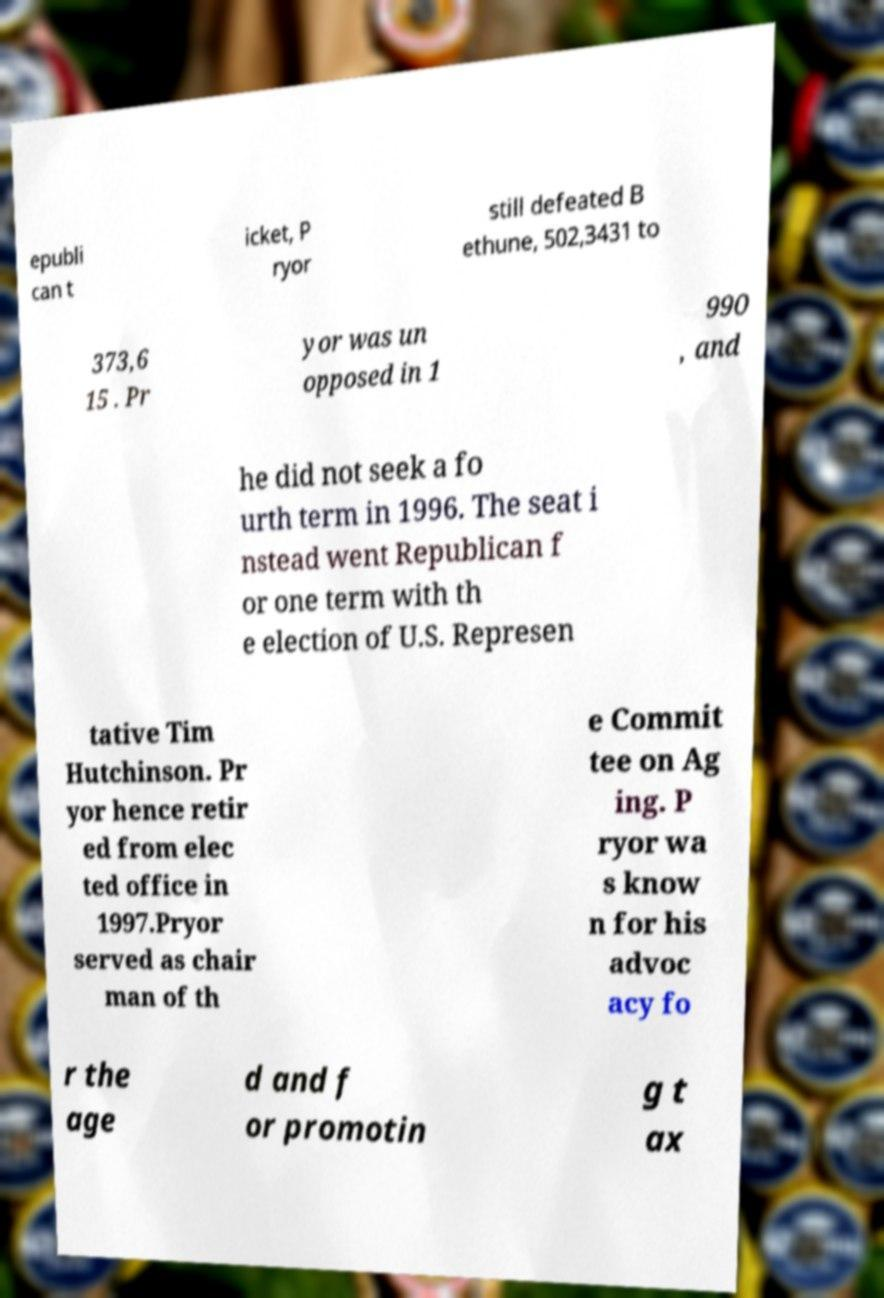Can you read and provide the text displayed in the image?This photo seems to have some interesting text. Can you extract and type it out for me? epubli can t icket, P ryor still defeated B ethune, 502,3431 to 373,6 15 . Pr yor was un opposed in 1 990 , and he did not seek a fo urth term in 1996. The seat i nstead went Republican f or one term with th e election of U.S. Represen tative Tim Hutchinson. Pr yor hence retir ed from elec ted office in 1997.Pryor served as chair man of th e Commit tee on Ag ing. P ryor wa s know n for his advoc acy fo r the age d and f or promotin g t ax 